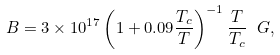<formula> <loc_0><loc_0><loc_500><loc_500>B = 3 \times 1 0 ^ { 1 7 } \left ( 1 + 0 . 0 9 \frac { T _ { c } } { T } \right ) ^ { - 1 } \frac { T } { T _ { c } } \ G ,</formula> 